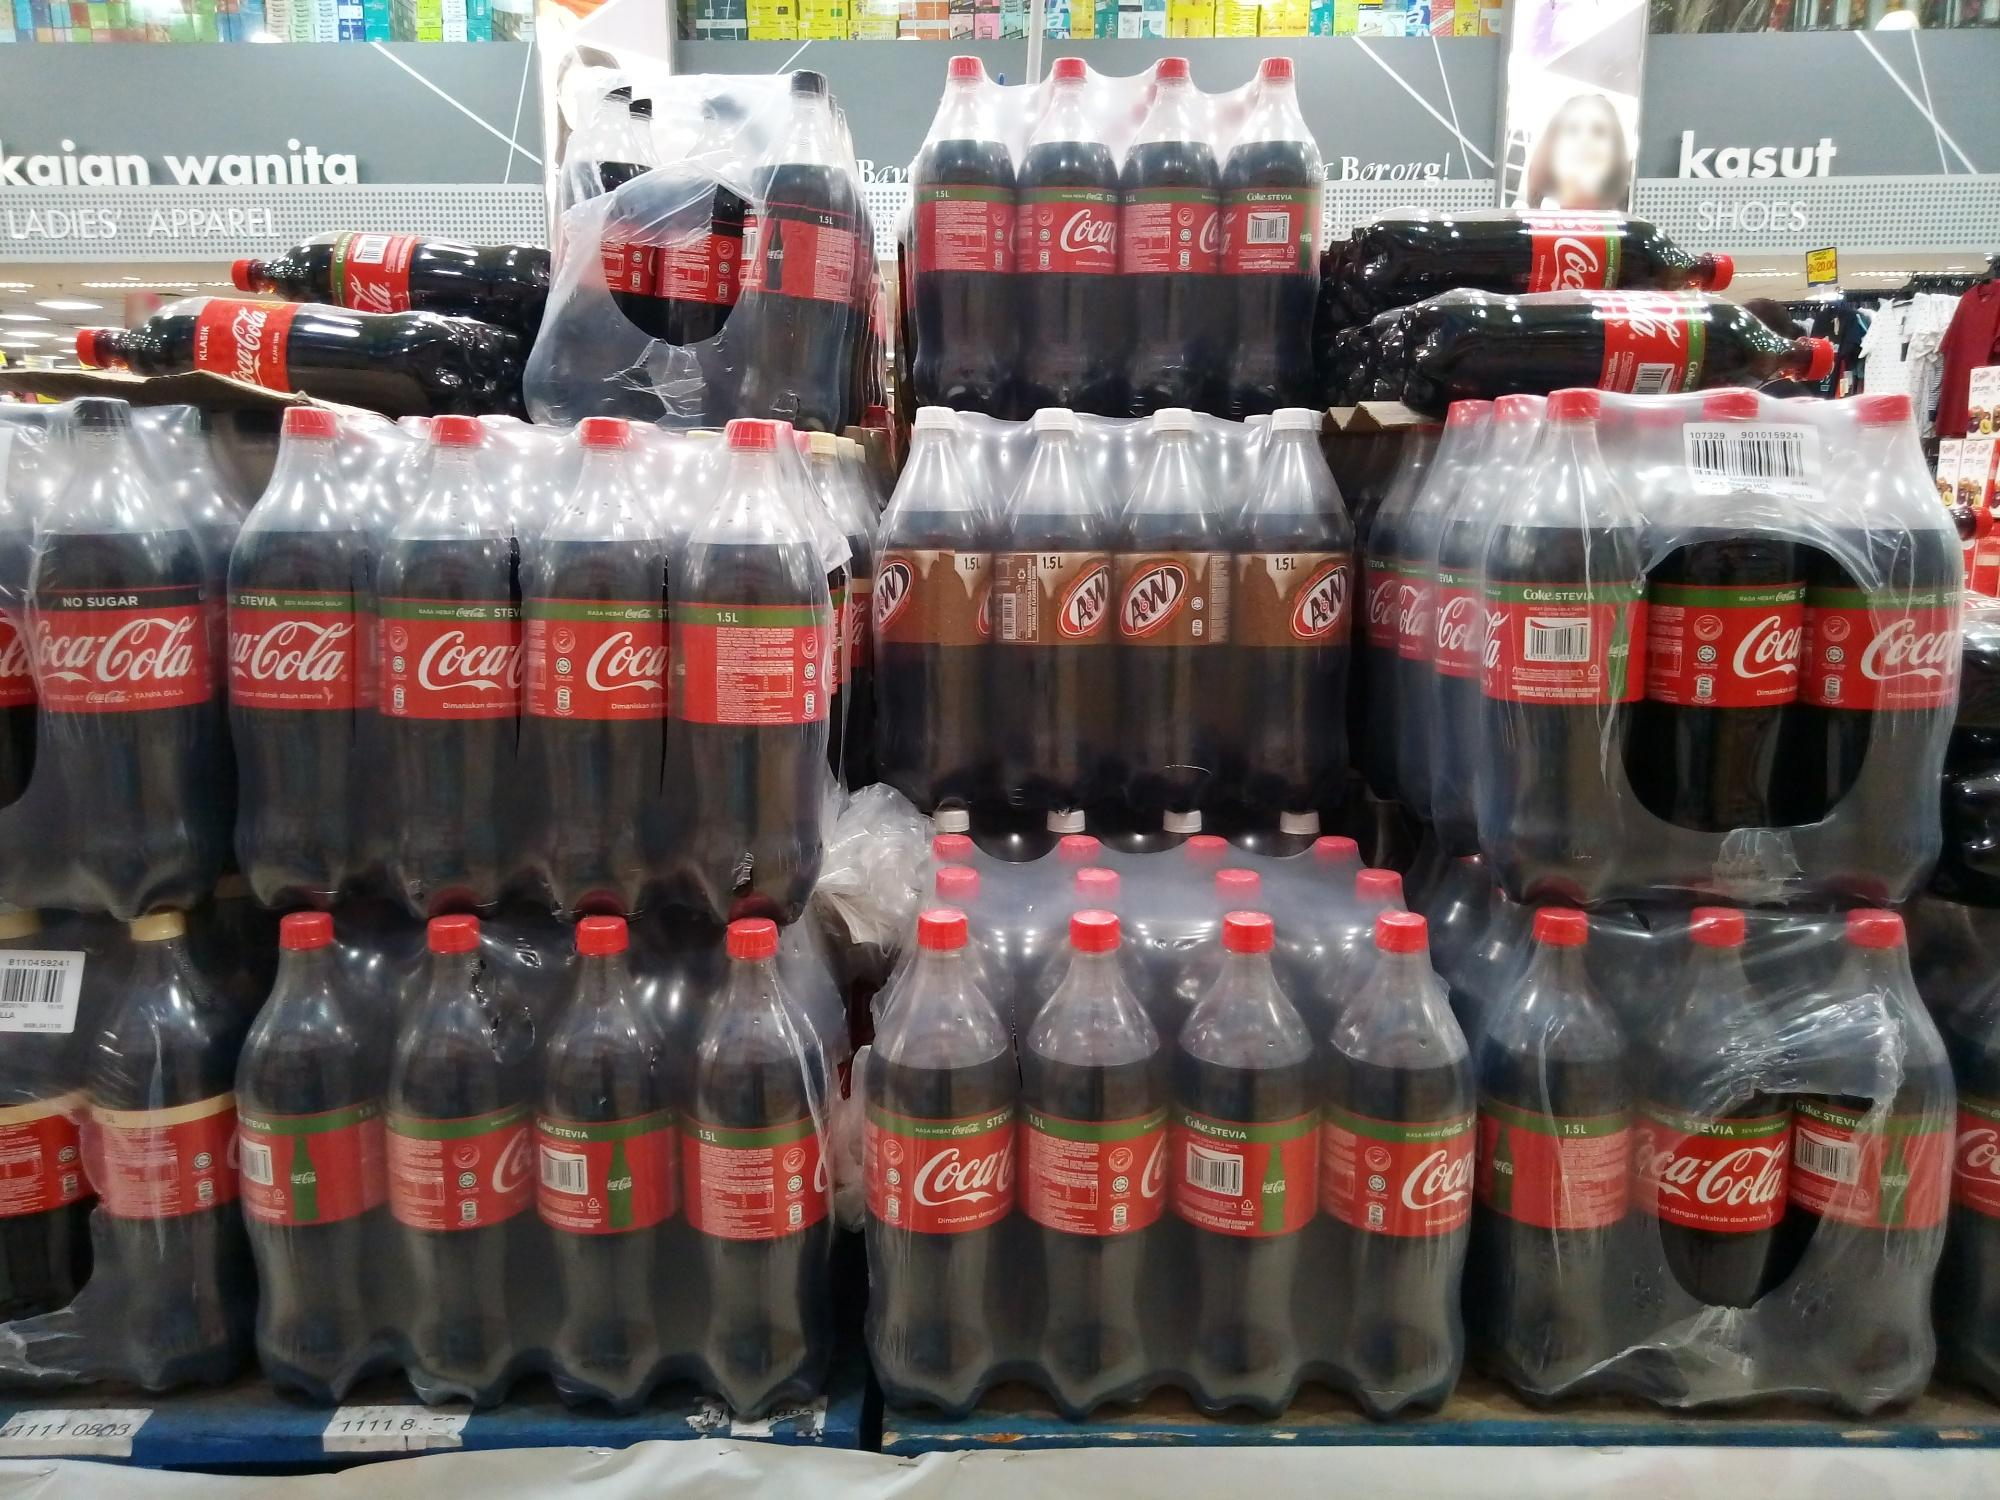Long and detailed description of how Coca-Cola could use this image for a holiday-themed advertisement. For a holiday-themed advertisement, this image could be transformed into a festive showcase, with the pyramid of Coca-Cola and A&W bottles at the center. Imagine a scene draped with holiday lights and adorned with decorative ornaments, transforming the display into a sparkling, inviting beacon. Snowflake decals could be added to the bottles, and festive music playing in the background would create a warm, celebratory atmosphere. The campaign slogan might be 'Share the Magic of the Holidays with Coca-Cola,' featuring families and friends coming together, clinking bottles in toasts, and sharing heartwarming moments. The surrounding retail environment could be decorated with garlands and holiday-themed signs, suggesting a bustling, joyful atmosphere. This combination of familiar brand elements with holiday cheer would evoke nostalgia and encourage consumers to incorporate these beverages into their festive traditions, making Coca-Cola a staple in their holiday celebrations. 